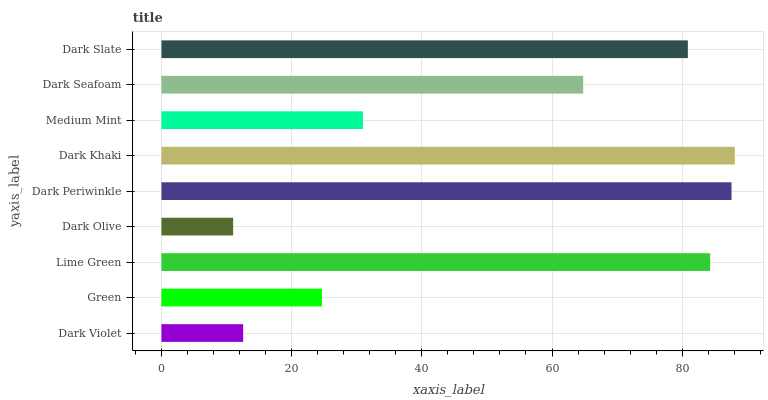Is Dark Olive the minimum?
Answer yes or no. Yes. Is Dark Khaki the maximum?
Answer yes or no. Yes. Is Green the minimum?
Answer yes or no. No. Is Green the maximum?
Answer yes or no. No. Is Green greater than Dark Violet?
Answer yes or no. Yes. Is Dark Violet less than Green?
Answer yes or no. Yes. Is Dark Violet greater than Green?
Answer yes or no. No. Is Green less than Dark Violet?
Answer yes or no. No. Is Dark Seafoam the high median?
Answer yes or no. Yes. Is Dark Seafoam the low median?
Answer yes or no. Yes. Is Lime Green the high median?
Answer yes or no. No. Is Dark Olive the low median?
Answer yes or no. No. 